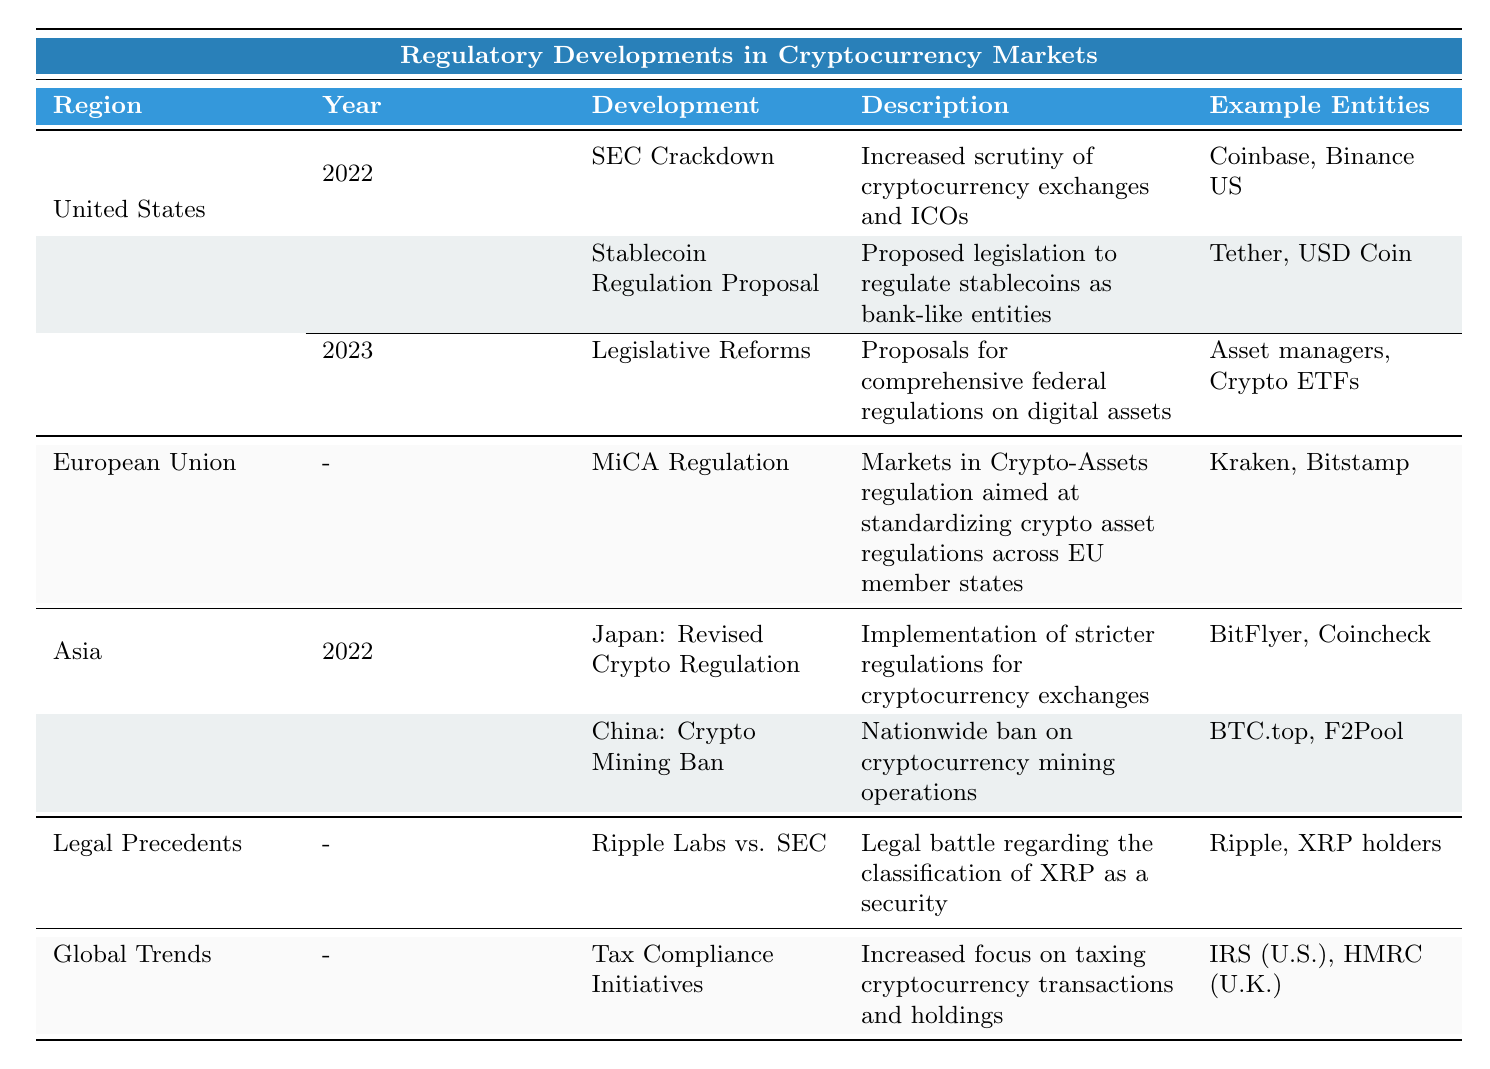What are the example entities involved in the SEC Crackdown in 2022? In the table under the United States section, within the 2022 row for SEC Crackdown, the example entities listed are Coinbase and Binance US.
Answer: Coinbase, Binance US Which regulatory development in the European Union is focused on investor protection? The table has a specific row for the European Union, mentioning the MiCA Regulation. The description indicates that this regulation aims at enhancing investor protection.
Answer: MiCA Regulation Is there a proposal for stablecoin regulation in the United States? According to the table, a regulatory development labeled "Stablecoin Regulation Proposal" is outlined under the United States section for 2022, indicating there was a proposal.
Answer: Yes What combination of developments occurred in the United States in 2022? In the table for the United States in 2022, there are two developments: the SEC Crackdown and the Stablecoin Regulation Proposal. These can be identified under the same year without combining with other years.
Answer: SEC Crackdown and Stablecoin Regulation Proposal Which entity faces legal scrutiny due to the Ripple Labs vs. SEC case? The table lists Ripple under the Legal Precedents section in connection with the Ripple Labs vs. SEC case, indicating that it is involved in this legal scrutiny concerning the classification of XRP.
Answer: Ripple How many regions mentioned have developments related to cryptocurrency regulations in 2022? The United States has two developments in 2022; Japan has one, totaling three developments from two regions (United States and Asia/Japan) as China is only mentioned with a ban and not having a new regulation that year.
Answer: Three 